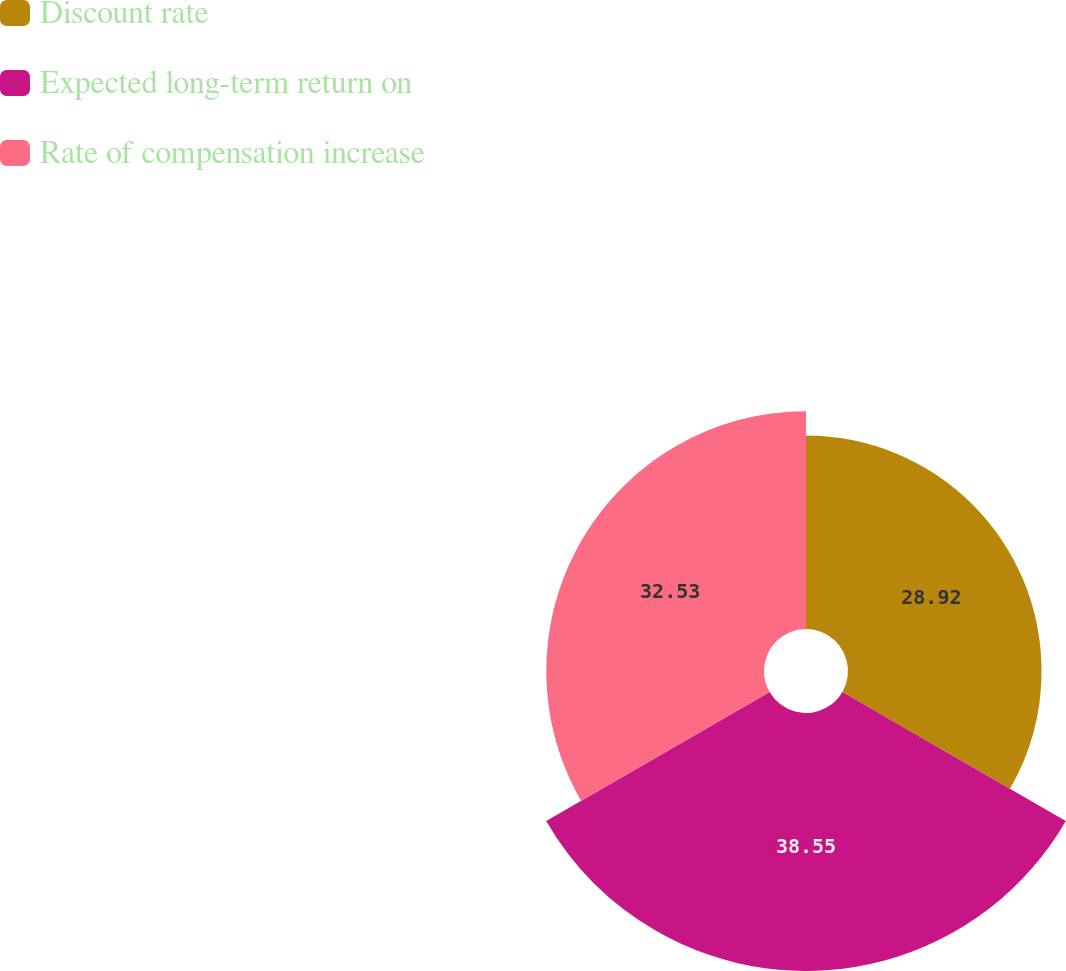Convert chart to OTSL. <chart><loc_0><loc_0><loc_500><loc_500><pie_chart><fcel>Discount rate<fcel>Expected long-term return on<fcel>Rate of compensation increase<nl><fcel>28.92%<fcel>38.55%<fcel>32.53%<nl></chart> 